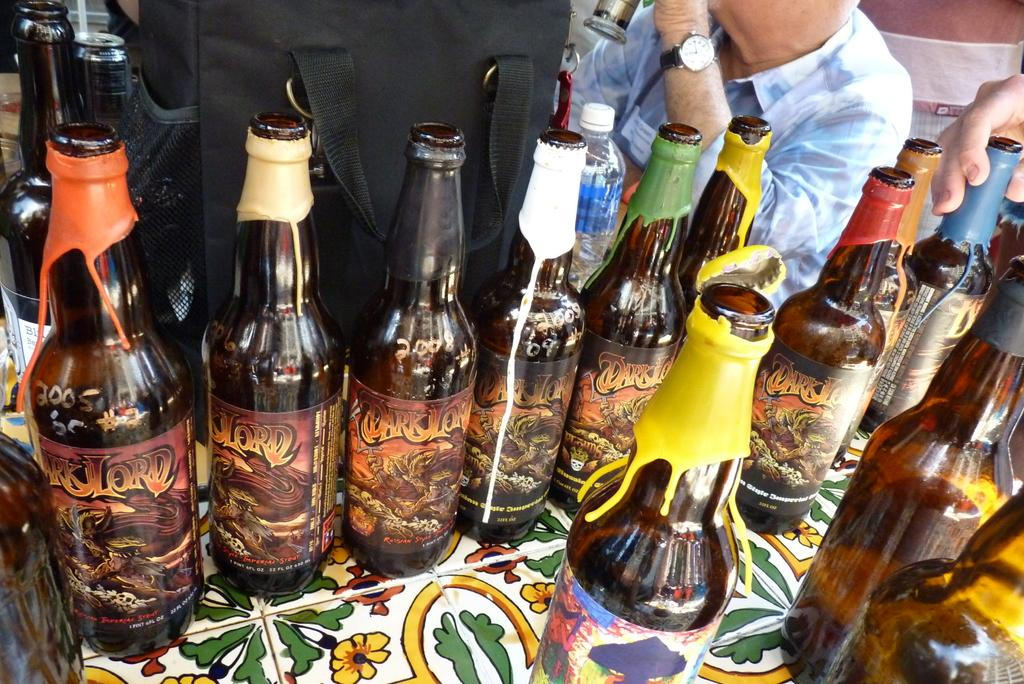<image>
Create a compact narrative representing the image presented. A row of Dark Lord bear bottles are lined up on a floral table cloth. 